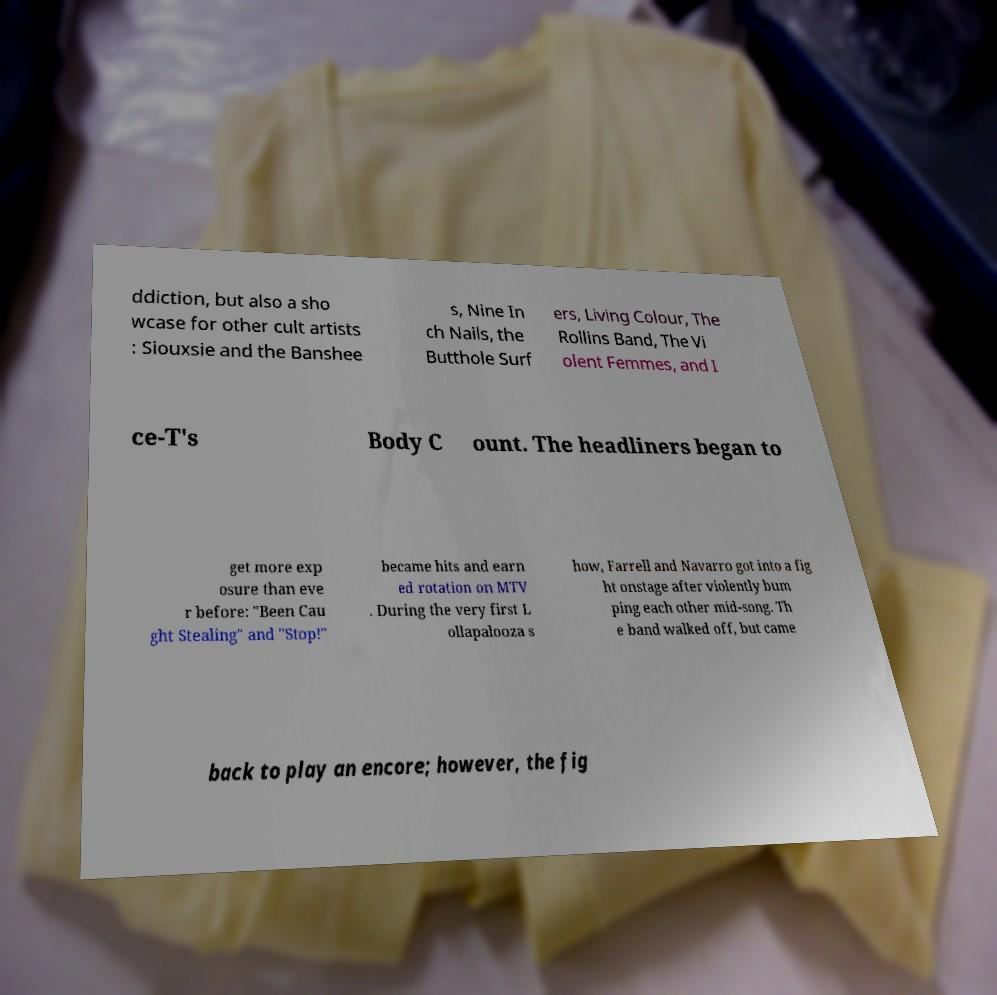Could you assist in decoding the text presented in this image and type it out clearly? ddiction, but also a sho wcase for other cult artists : Siouxsie and the Banshee s, Nine In ch Nails, the Butthole Surf ers, Living Colour, The Rollins Band, The Vi olent Femmes, and I ce-T's Body C ount. The headliners began to get more exp osure than eve r before: "Been Cau ght Stealing" and "Stop!" became hits and earn ed rotation on MTV . During the very first L ollapalooza s how, Farrell and Navarro got into a fig ht onstage after violently bum ping each other mid-song. Th e band walked off, but came back to play an encore; however, the fig 